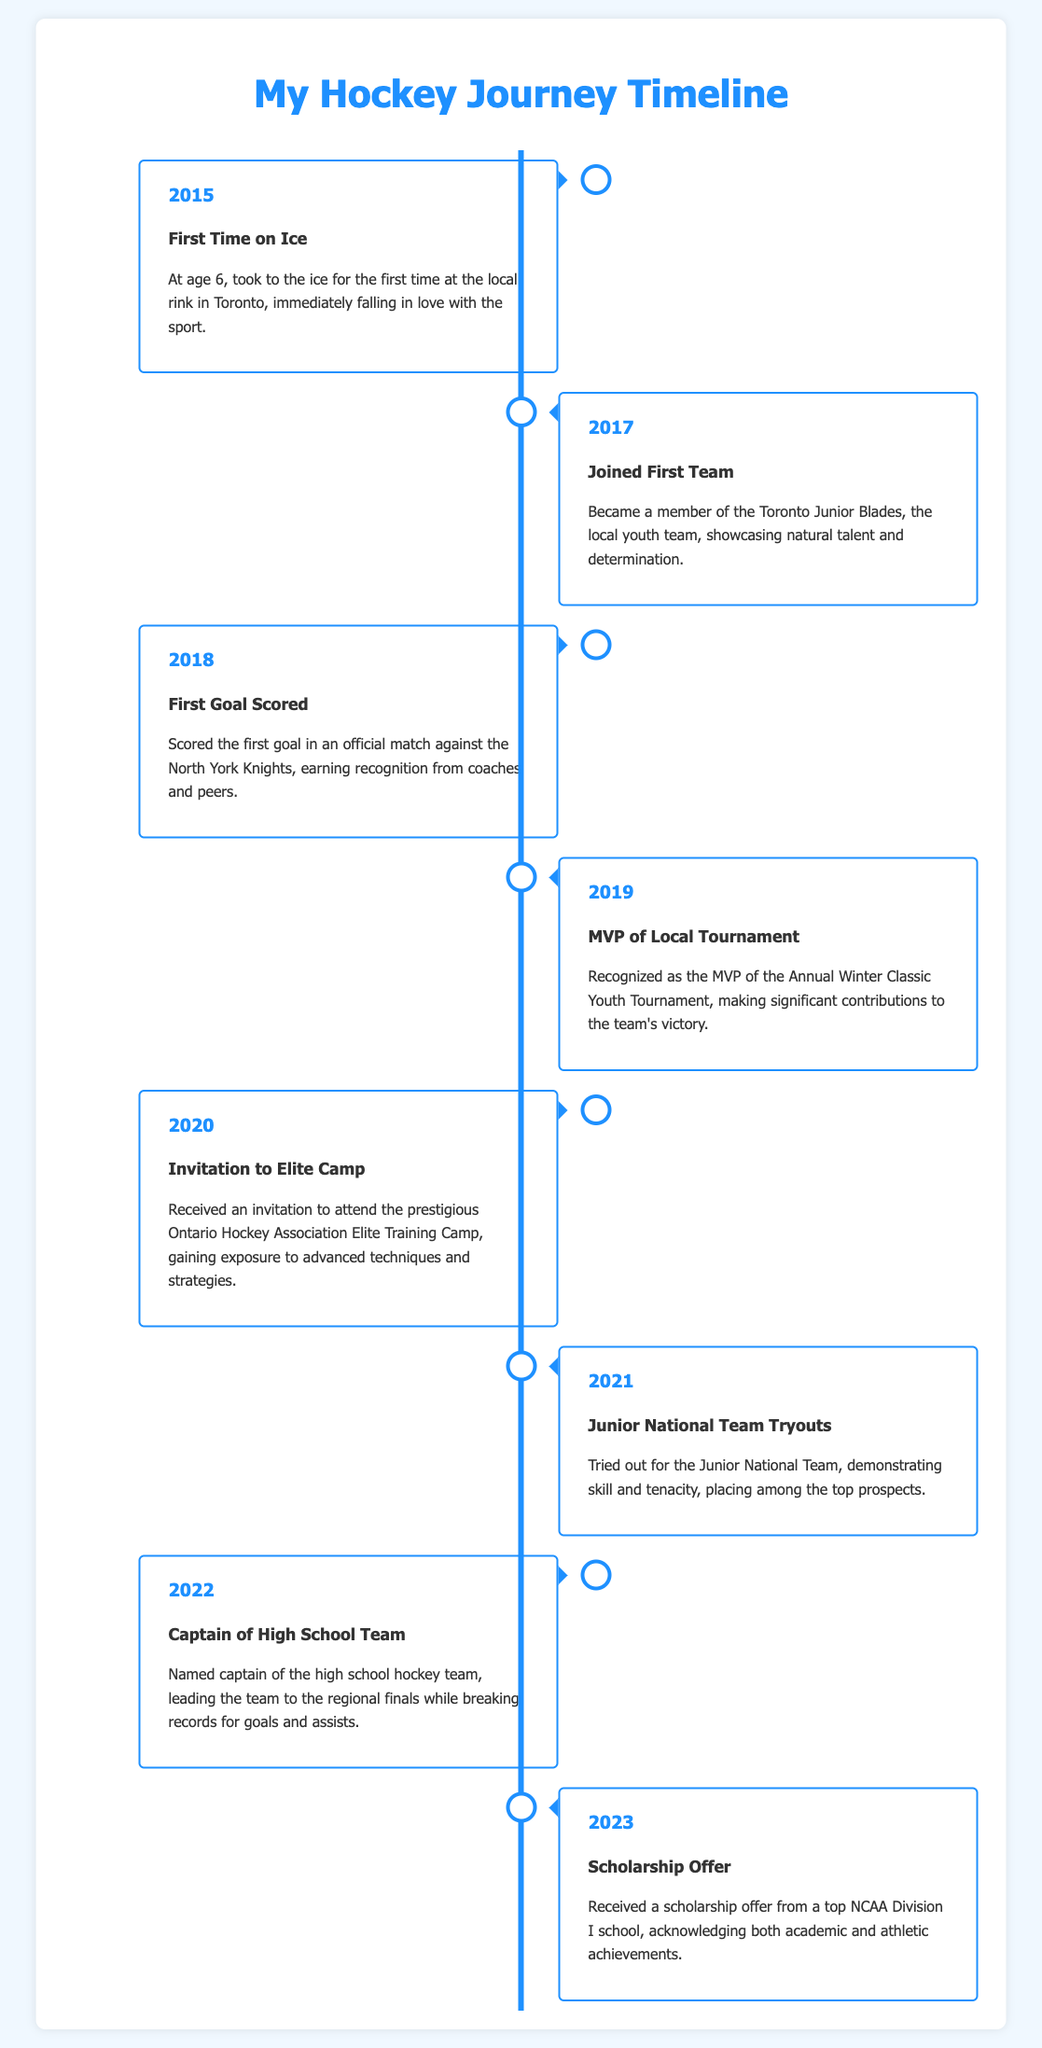What year did you first skate on ice? The year of the first time on ice is mentioned in the first event, which was 2015.
Answer: 2015 What was the title of your first team? The title of the first team is specified in the second event, which is the Toronto Junior Blades.
Answer: Toronto Junior Blades Which event recognized you as the MVP? The specific event that recognized the MVP status is mentioned as the Annual Winter Classic Youth Tournament in 2019.
Answer: Annual Winter Classic Youth Tournament In what year did you receive a scholarship offer? The year a scholarship offer was received is mentioned in the last event, which was in 2023.
Answer: 2023 How many years were there between your first goal scored and receiving an invitation to elite camp? The first goal was scored in 2018 and the invitation to elite camp was in 2020; the difference is 2 years.
Answer: 2 years What position did you hold in your high school team? The position held in the high school team was captain, mentioned in the event for the year 2022.
Answer: Captain What achievement was highlighted in the 2021 event? The achievement highlighted in 2021 was trying out for the Junior National Team.
Answer: Junior National Team Tryouts What is the primary theme of this timeline infographic? The primary theme of the timeline is your personal journey and achievements in hockey.
Answer: Personal journey and achievements in hockey 